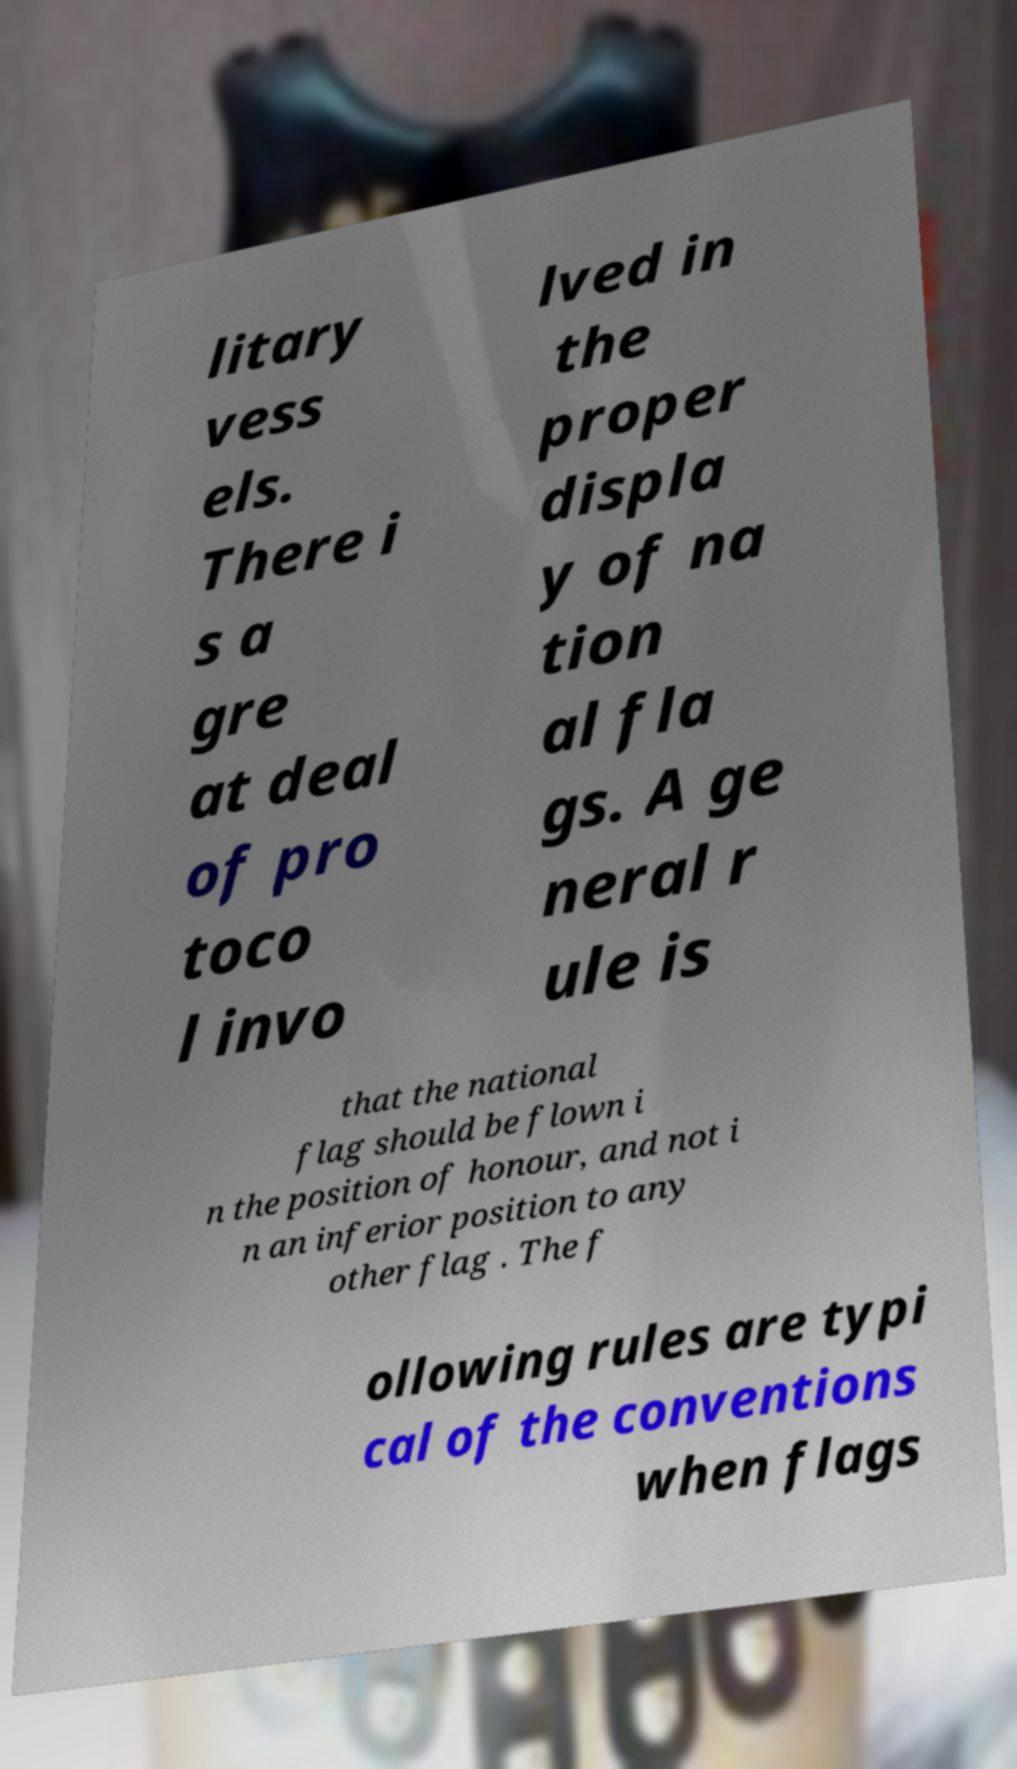Could you assist in decoding the text presented in this image and type it out clearly? litary vess els. There i s a gre at deal of pro toco l invo lved in the proper displa y of na tion al fla gs. A ge neral r ule is that the national flag should be flown i n the position of honour, and not i n an inferior position to any other flag . The f ollowing rules are typi cal of the conventions when flags 